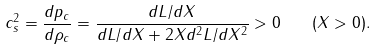Convert formula to latex. <formula><loc_0><loc_0><loc_500><loc_500>c _ { s } ^ { 2 } = \frac { d p _ { c } } { d \rho _ { c } } = \frac { d L / d X } { d L / d X + 2 X d ^ { 2 } L / d X ^ { 2 } } > 0 \quad ( X > 0 ) .</formula> 